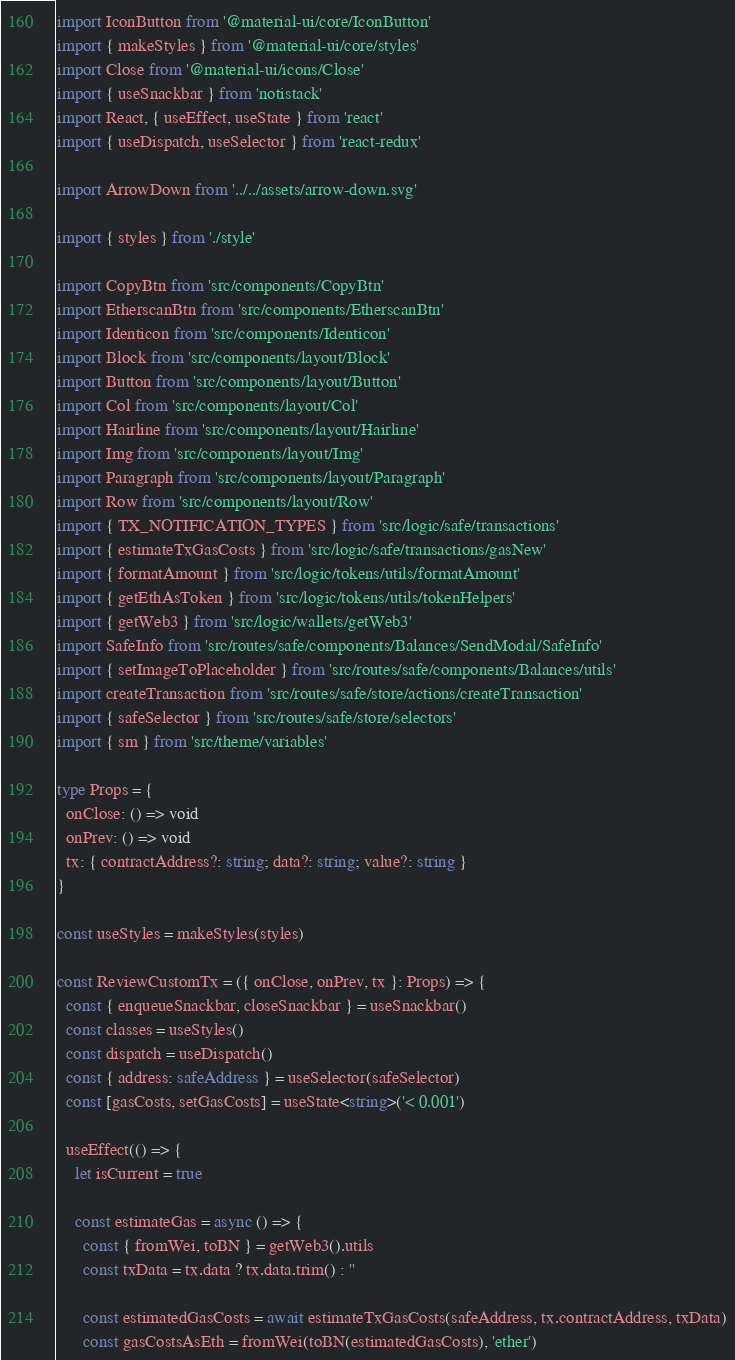<code> <loc_0><loc_0><loc_500><loc_500><_TypeScript_>import IconButton from '@material-ui/core/IconButton'
import { makeStyles } from '@material-ui/core/styles'
import Close from '@material-ui/icons/Close'
import { useSnackbar } from 'notistack'
import React, { useEffect, useState } from 'react'
import { useDispatch, useSelector } from 'react-redux'

import ArrowDown from '../../assets/arrow-down.svg'

import { styles } from './style'

import CopyBtn from 'src/components/CopyBtn'
import EtherscanBtn from 'src/components/EtherscanBtn'
import Identicon from 'src/components/Identicon'
import Block from 'src/components/layout/Block'
import Button from 'src/components/layout/Button'
import Col from 'src/components/layout/Col'
import Hairline from 'src/components/layout/Hairline'
import Img from 'src/components/layout/Img'
import Paragraph from 'src/components/layout/Paragraph'
import Row from 'src/components/layout/Row'
import { TX_NOTIFICATION_TYPES } from 'src/logic/safe/transactions'
import { estimateTxGasCosts } from 'src/logic/safe/transactions/gasNew'
import { formatAmount } from 'src/logic/tokens/utils/formatAmount'
import { getEthAsToken } from 'src/logic/tokens/utils/tokenHelpers'
import { getWeb3 } from 'src/logic/wallets/getWeb3'
import SafeInfo from 'src/routes/safe/components/Balances/SendModal/SafeInfo'
import { setImageToPlaceholder } from 'src/routes/safe/components/Balances/utils'
import createTransaction from 'src/routes/safe/store/actions/createTransaction'
import { safeSelector } from 'src/routes/safe/store/selectors'
import { sm } from 'src/theme/variables'

type Props = {
  onClose: () => void
  onPrev: () => void
  tx: { contractAddress?: string; data?: string; value?: string }
}

const useStyles = makeStyles(styles)

const ReviewCustomTx = ({ onClose, onPrev, tx }: Props) => {
  const { enqueueSnackbar, closeSnackbar } = useSnackbar()
  const classes = useStyles()
  const dispatch = useDispatch()
  const { address: safeAddress } = useSelector(safeSelector)
  const [gasCosts, setGasCosts] = useState<string>('< 0.001')

  useEffect(() => {
    let isCurrent = true

    const estimateGas = async () => {
      const { fromWei, toBN } = getWeb3().utils
      const txData = tx.data ? tx.data.trim() : ''

      const estimatedGasCosts = await estimateTxGasCosts(safeAddress, tx.contractAddress, txData)
      const gasCostsAsEth = fromWei(toBN(estimatedGasCosts), 'ether')</code> 